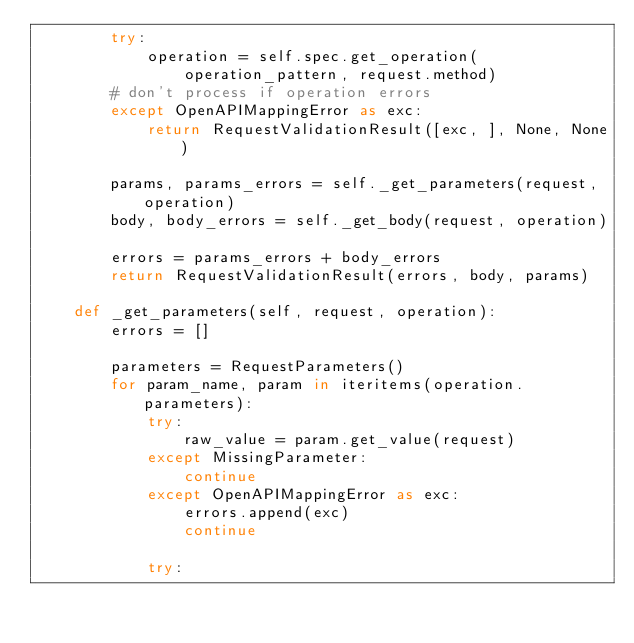<code> <loc_0><loc_0><loc_500><loc_500><_Python_>        try:
            operation = self.spec.get_operation(
                operation_pattern, request.method)
        # don't process if operation errors
        except OpenAPIMappingError as exc:
            return RequestValidationResult([exc, ], None, None)

        params, params_errors = self._get_parameters(request, operation)
        body, body_errors = self._get_body(request, operation)

        errors = params_errors + body_errors
        return RequestValidationResult(errors, body, params)

    def _get_parameters(self, request, operation):
        errors = []

        parameters = RequestParameters()
        for param_name, param in iteritems(operation.parameters):
            try:
                raw_value = param.get_value(request)
            except MissingParameter:
                continue
            except OpenAPIMappingError as exc:
                errors.append(exc)
                continue

            try:</code> 